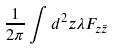<formula> <loc_0><loc_0><loc_500><loc_500>\frac { 1 } { 2 \pi } \int d ^ { 2 } z \lambda F _ { z \bar { z } }</formula> 